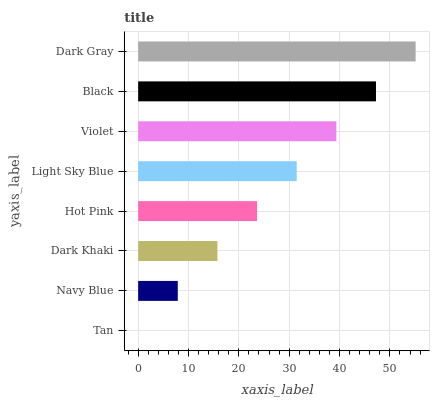Is Tan the minimum?
Answer yes or no. Yes. Is Dark Gray the maximum?
Answer yes or no. Yes. Is Navy Blue the minimum?
Answer yes or no. No. Is Navy Blue the maximum?
Answer yes or no. No. Is Navy Blue greater than Tan?
Answer yes or no. Yes. Is Tan less than Navy Blue?
Answer yes or no. Yes. Is Tan greater than Navy Blue?
Answer yes or no. No. Is Navy Blue less than Tan?
Answer yes or no. No. Is Light Sky Blue the high median?
Answer yes or no. Yes. Is Hot Pink the low median?
Answer yes or no. Yes. Is Violet the high median?
Answer yes or no. No. Is Violet the low median?
Answer yes or no. No. 